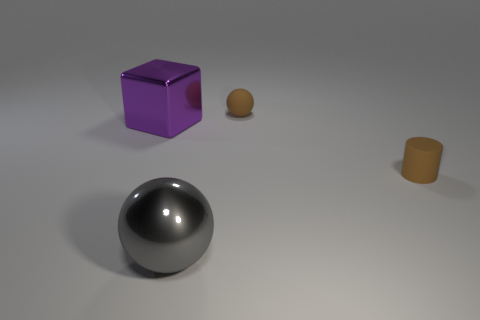Add 4 large gray balls. How many objects exist? 8 Subtract all cubes. How many objects are left? 3 Subtract 1 cylinders. How many cylinders are left? 0 Subtract all blue balls. Subtract all yellow cylinders. How many balls are left? 2 Subtract all large purple shiny cubes. Subtract all large objects. How many objects are left? 1 Add 1 tiny brown balls. How many tiny brown balls are left? 2 Add 1 tiny things. How many tiny things exist? 3 Subtract all gray balls. How many balls are left? 1 Subtract 0 red cubes. How many objects are left? 4 